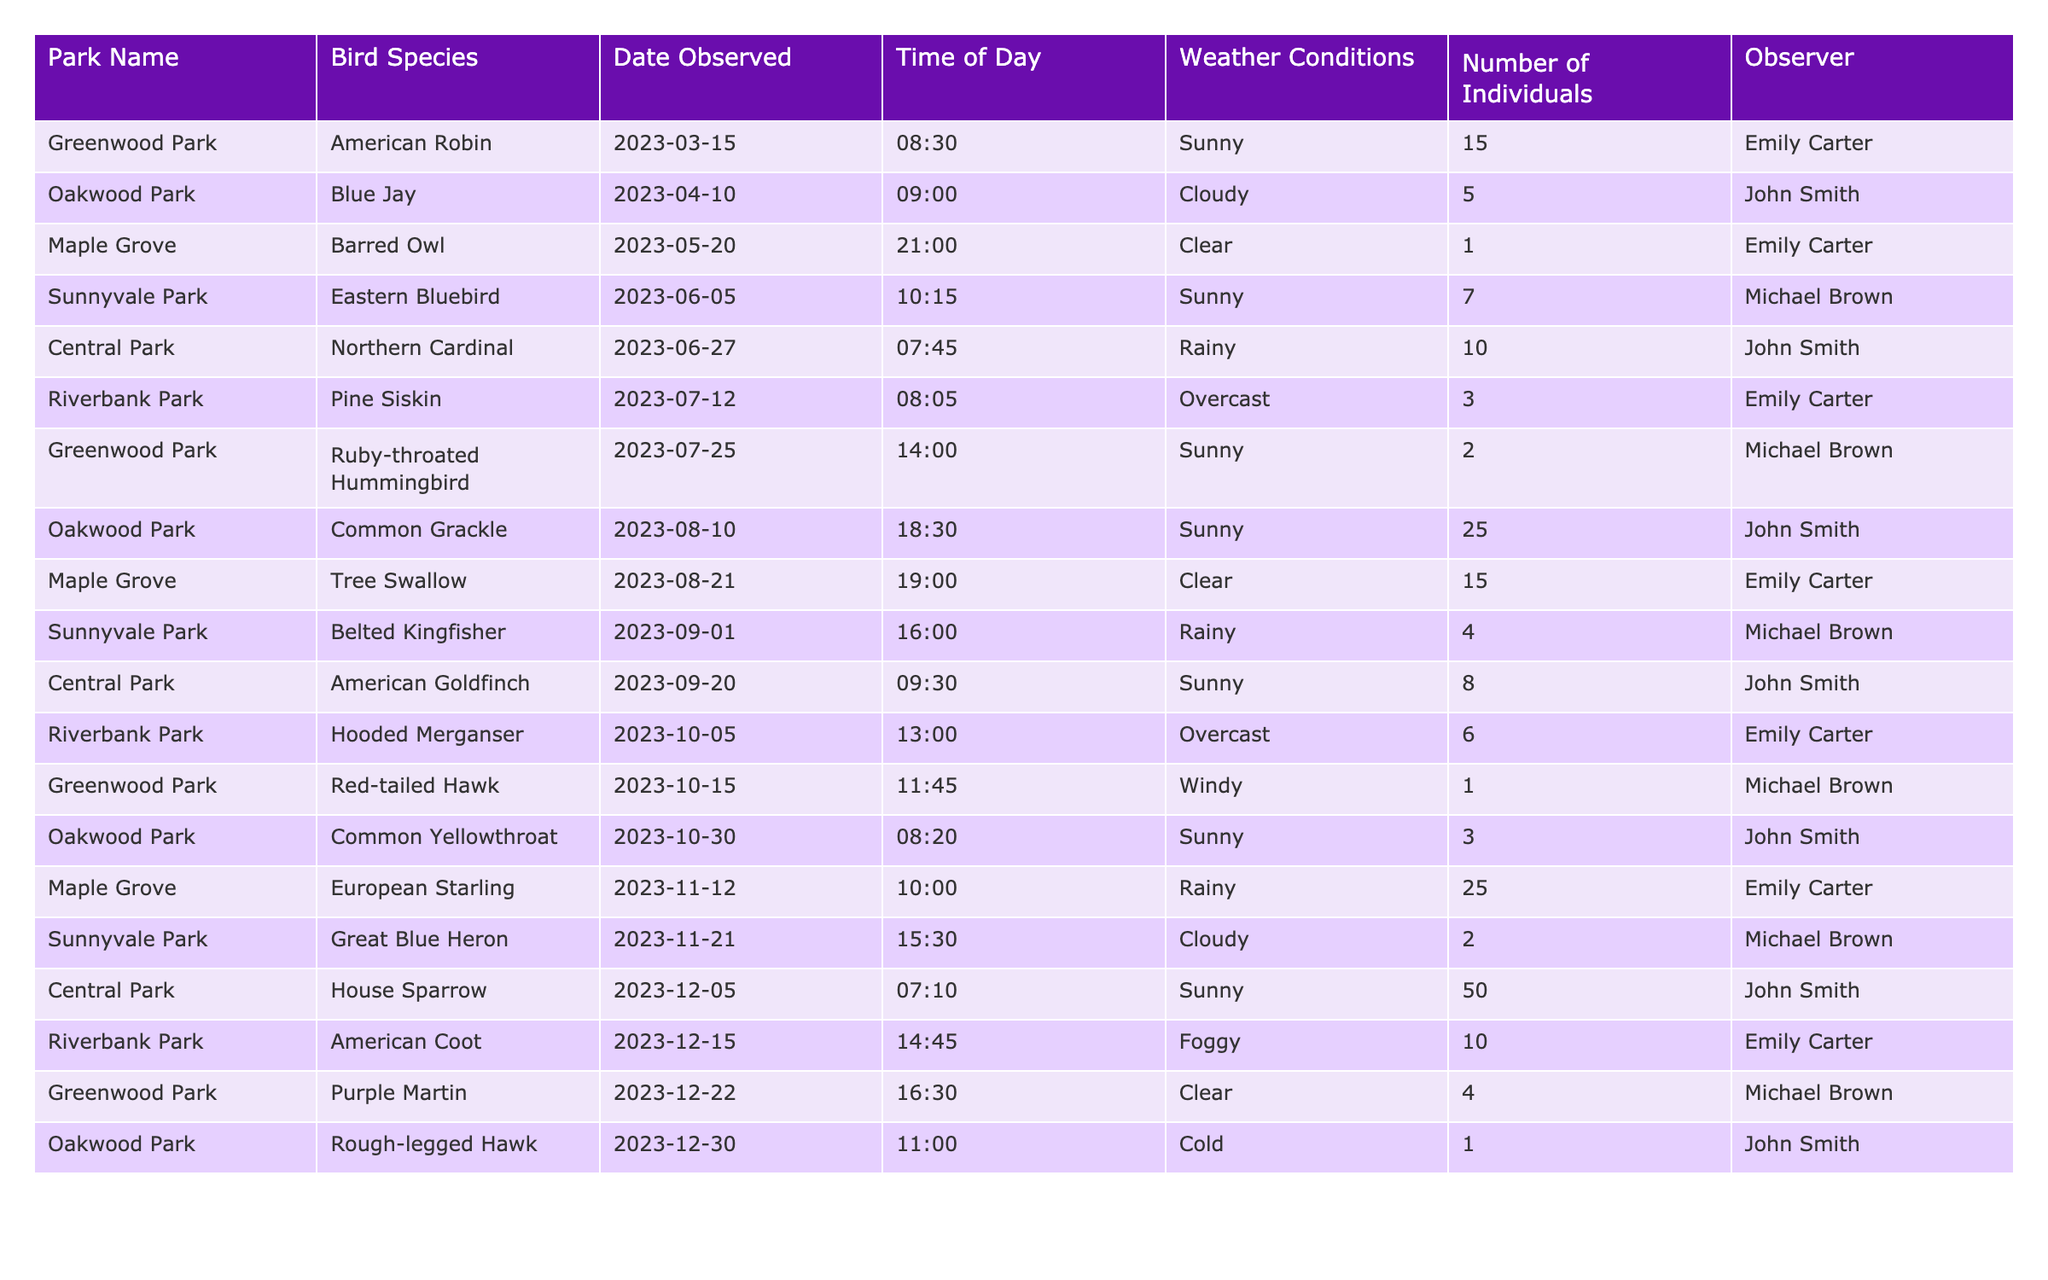What is the total number of observations made in Sunnyvale Park? In Sunnyvale Park, the observations made are the Eastern Bluebird (7 individuals), Belted Kingfisher (4 individuals), and Great Blue Heron (2 individuals). Adding these together gives 7 + 4 + 2 = 13.
Answer: 13 Which bird species was observed the most in Central Park? In Central Park, the bird species observed were Northern Cardinal (10 individuals), American Goldfinch (8 individuals), and House Sparrow (50 individuals). The species with the highest count is House Sparrow with 50 individuals.
Answer: House Sparrow How many different bird species were observed in Maple Grove? In Maple Grove, the observed species are Barred Owl, Tree Swallow, and European Starling. This totals to 3 different bird species.
Answer: 3 True or False: The American Robin was observed in Greenwood Park. The data shows that the American Robin was observed in Greenwood Park on 2023-03-15. Thus, the statement is true.
Answer: True What is the average number of individuals observed across all parks? To find the average, sum the number of individuals (15 + 5 + 1 + 7 + 10 + 3 + 2 + 25 + 15 + 4 + 8 + 6 + 1 + 3 + 25 + 2 + 50 + 10 + 4 + 1) which equals 139. There are 20 observations, so the average is 139 / 20 = 6.95.
Answer: 6.95 Which park had the highest observation count in a single day? In Oakwood Park, the Common Grackle was observed with 25 individuals on 2023-08-10, which is the highest count for a single observation in one day compared to other parks.
Answer: Oakwood Park How many species were observed in the month of December? The species observed in December are House Sparrow, American Coot, and Purple Martin. Therefore, 3 different bird species were observed in December.
Answer: 3 What was the weather condition during the observation of the Barred Owl? The Barred Owl was observed in Maple Grove on 2023-05-20 with clear weather conditions.
Answer: Clear Which observer recorded the most bird species sightings? By counting the number of different bird species each observer recorded, Emily Carter observed 5 species (American Robin, Barred Owl, Pine Siskin, Tree Swallow, and Hooded Merganser) while John Smith recorded 5 species as well (Blue Jay, Northern Cardinal, Common Grackle, American Goldfinch, House Sparrow) and Michael Brown recorded 5 species (Eastern Bluebird, Ruby-throated Hummingbird, Belted Kingfisher, Great Blue Heron, Purple Martin). They each recorded an equal number of different species.
Answer: Tie between Emily Carter, John Smith, and Michael Brown Which park had the largest number of individuals for the bird species observed? The largest number of individuals was the House Sparrow observed in Central Park with 50 individuals, making it the park with the largest count.
Answer: Central Park 